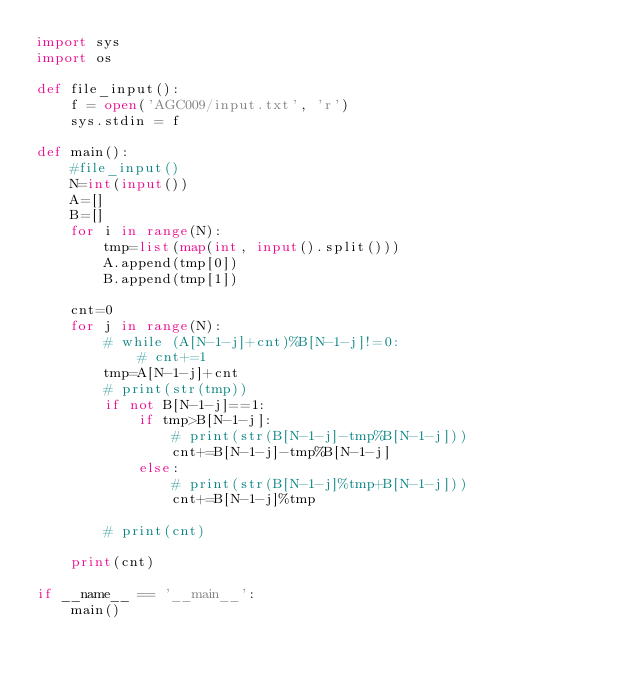Convert code to text. <code><loc_0><loc_0><loc_500><loc_500><_Python_>import sys
import os

def file_input():
    f = open('AGC009/input.txt', 'r')
    sys.stdin = f

def main():
    #file_input()
    N=int(input())
    A=[]
    B=[]
    for i in range(N):
        tmp=list(map(int, input().split()))
        A.append(tmp[0])
        B.append(tmp[1])

    cnt=0
    for j in range(N):
        # while (A[N-1-j]+cnt)%B[N-1-j]!=0:
            # cnt+=1
        tmp=A[N-1-j]+cnt
        # print(str(tmp))
        if not B[N-1-j]==1:
            if tmp>B[N-1-j]:
                # print(str(B[N-1-j]-tmp%B[N-1-j]))
                cnt+=B[N-1-j]-tmp%B[N-1-j]
            else:
                # print(str(B[N-1-j]%tmp+B[N-1-j]))
                cnt+=B[N-1-j]%tmp

        # print(cnt)

    print(cnt)

if __name__ == '__main__':
    main()
</code> 